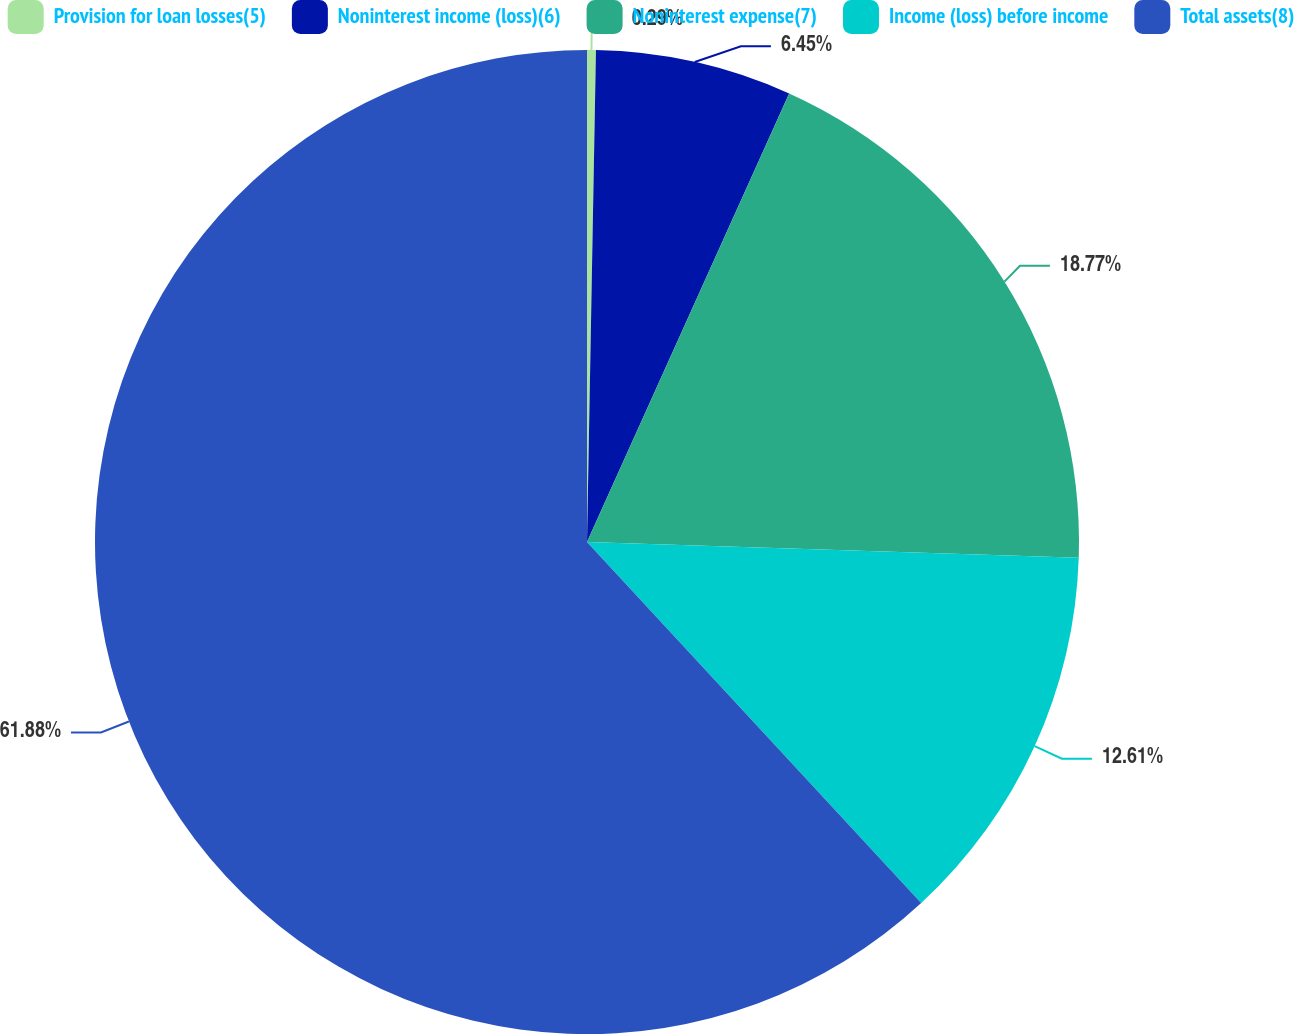Convert chart. <chart><loc_0><loc_0><loc_500><loc_500><pie_chart><fcel>Provision for loan losses(5)<fcel>Noninterest income (loss)(6)<fcel>Noninterest expense(7)<fcel>Income (loss) before income<fcel>Total assets(8)<nl><fcel>0.29%<fcel>6.45%<fcel>18.77%<fcel>12.61%<fcel>61.89%<nl></chart> 